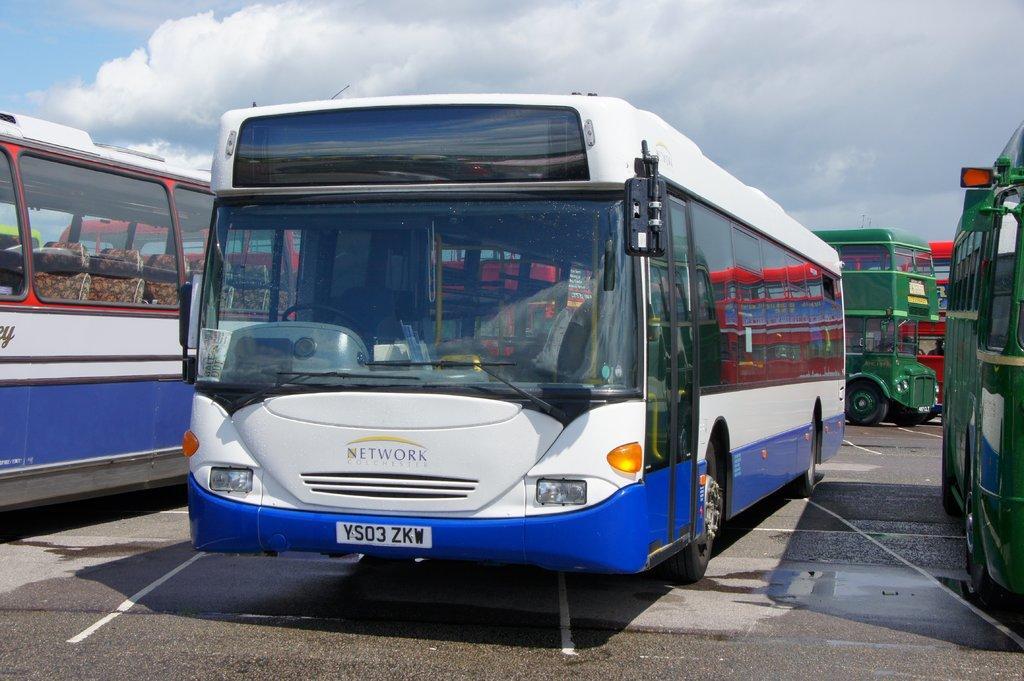How would you summarize this image in a sentence or two? In this image I can see two buses which are white and blue in color and few other buses which are green and red in color on the ground. In the background I can see the sky. 